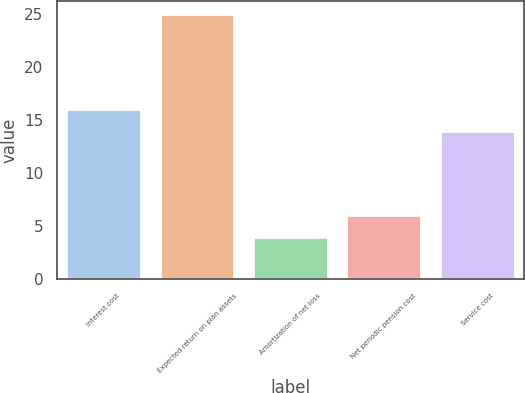<chart> <loc_0><loc_0><loc_500><loc_500><bar_chart><fcel>Interest cost<fcel>Expected return on plan assets<fcel>Amortization of net loss<fcel>Net periodic pension cost<fcel>Service cost<nl><fcel>16.1<fcel>25<fcel>4<fcel>6.1<fcel>14<nl></chart> 